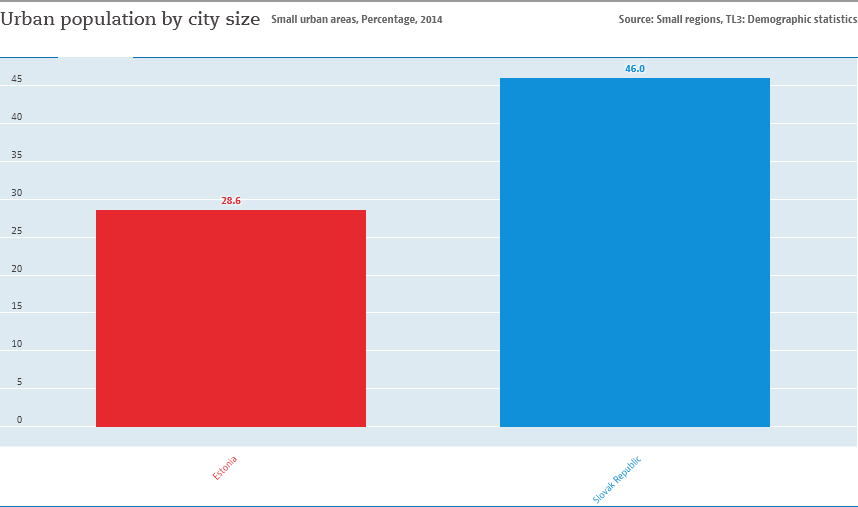Draw attention to some important aspects in this diagram. The city with the highest urban population in the Slovak Republic is . The sum of Estonia and Slovak Republic is 74.6. 